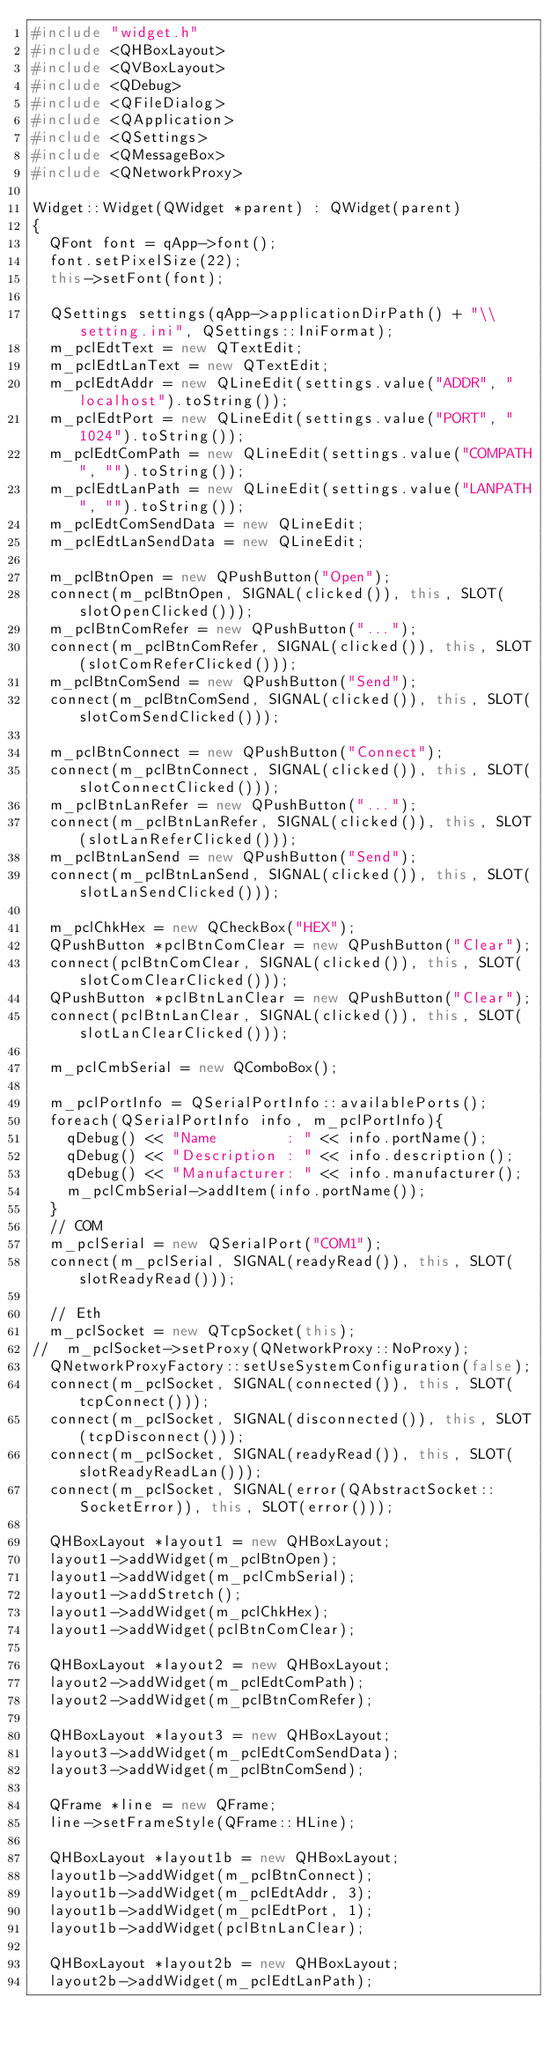<code> <loc_0><loc_0><loc_500><loc_500><_C++_>#include "widget.h"
#include <QHBoxLayout>
#include <QVBoxLayout>
#include <QDebug>
#include <QFileDialog>
#include <QApplication>
#include <QSettings>
#include <QMessageBox>
#include <QNetworkProxy>

Widget::Widget(QWidget *parent) : QWidget(parent)
{
	QFont font = qApp->font();
	font.setPixelSize(22);
	this->setFont(font);

	QSettings settings(qApp->applicationDirPath() + "\\setting.ini", QSettings::IniFormat);
	m_pclEdtText = new QTextEdit;
	m_pclEdtLanText = new QTextEdit;
	m_pclEdtAddr = new QLineEdit(settings.value("ADDR", "localhost").toString());
	m_pclEdtPort = new QLineEdit(settings.value("PORT", "1024").toString());
	m_pclEdtComPath = new QLineEdit(settings.value("COMPATH", "").toString());
	m_pclEdtLanPath = new QLineEdit(settings.value("LANPATH", "").toString());
	m_pclEdtComSendData = new QLineEdit;
	m_pclEdtLanSendData = new QLineEdit;

	m_pclBtnOpen = new QPushButton("Open");
	connect(m_pclBtnOpen, SIGNAL(clicked()), this, SLOT(slotOpenClicked()));
	m_pclBtnComRefer = new QPushButton("...");
	connect(m_pclBtnComRefer, SIGNAL(clicked()), this, SLOT(slotComReferClicked()));
	m_pclBtnComSend = new QPushButton("Send");
	connect(m_pclBtnComSend, SIGNAL(clicked()), this, SLOT(slotComSendClicked()));

	m_pclBtnConnect = new QPushButton("Connect");
	connect(m_pclBtnConnect, SIGNAL(clicked()), this, SLOT(slotConnectClicked()));
	m_pclBtnLanRefer = new QPushButton("...");
	connect(m_pclBtnLanRefer, SIGNAL(clicked()), this, SLOT(slotLanReferClicked()));
	m_pclBtnLanSend = new QPushButton("Send");
	connect(m_pclBtnLanSend, SIGNAL(clicked()), this, SLOT(slotLanSendClicked()));

	m_pclChkHex = new QCheckBox("HEX");
	QPushButton *pclBtnComClear = new QPushButton("Clear");
	connect(pclBtnComClear, SIGNAL(clicked()), this, SLOT(slotComClearClicked()));
	QPushButton *pclBtnLanClear = new QPushButton("Clear");
	connect(pclBtnLanClear, SIGNAL(clicked()), this, SLOT(slotLanClearClicked()));

	m_pclCmbSerial = new QComboBox();

	m_pclPortInfo = QSerialPortInfo::availablePorts();
	foreach(QSerialPortInfo info, m_pclPortInfo){
		qDebug() << "Name        : " << info.portName();
		qDebug() << "Description : " << info.description();
		qDebug() << "Manufacturer: " << info.manufacturer();
		m_pclCmbSerial->addItem(info.portName());
	}
	// COM
	m_pclSerial = new QSerialPort("COM1");
	connect(m_pclSerial, SIGNAL(readyRead()), this, SLOT(slotReadyRead()));

	// Eth
	m_pclSocket = new QTcpSocket(this);
//	m_pclSocket->setProxy(QNetworkProxy::NoProxy);
	QNetworkProxyFactory::setUseSystemConfiguration(false);
	connect(m_pclSocket, SIGNAL(connected()), this, SLOT(tcpConnect()));
	connect(m_pclSocket, SIGNAL(disconnected()), this, SLOT(tcpDisconnect()));
	connect(m_pclSocket, SIGNAL(readyRead()), this, SLOT(slotReadyReadLan()));
	connect(m_pclSocket, SIGNAL(error(QAbstractSocket::SocketError)), this, SLOT(error()));

	QHBoxLayout *layout1 = new QHBoxLayout;
	layout1->addWidget(m_pclBtnOpen);
	layout1->addWidget(m_pclCmbSerial);
	layout1->addStretch();
	layout1->addWidget(m_pclChkHex);
	layout1->addWidget(pclBtnComClear);

	QHBoxLayout *layout2 = new QHBoxLayout;
	layout2->addWidget(m_pclEdtComPath);
	layout2->addWidget(m_pclBtnComRefer);

	QHBoxLayout *layout3 = new QHBoxLayout;
	layout3->addWidget(m_pclEdtComSendData);
	layout3->addWidget(m_pclBtnComSend);

	QFrame *line = new QFrame;
	line->setFrameStyle(QFrame::HLine);

	QHBoxLayout *layout1b = new QHBoxLayout;
	layout1b->addWidget(m_pclBtnConnect);
	layout1b->addWidget(m_pclEdtAddr, 3);
	layout1b->addWidget(m_pclEdtPort, 1);
	layout1b->addWidget(pclBtnLanClear);

	QHBoxLayout *layout2b = new QHBoxLayout;
	layout2b->addWidget(m_pclEdtLanPath);</code> 